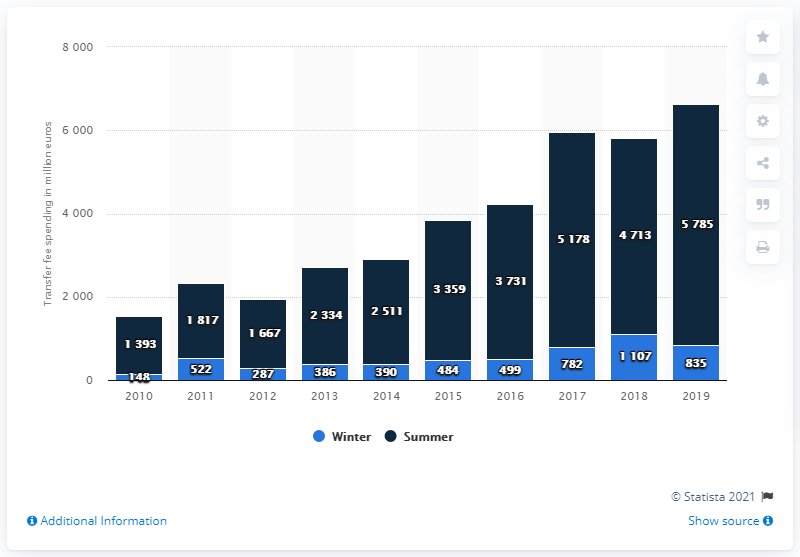Draw attention to some important aspects in this diagram. In the summer of 2019, the big-5 collectively spent 5785. 